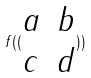Convert formula to latex. <formula><loc_0><loc_0><loc_500><loc_500>f ( ( \begin{matrix} a & b \\ c & d \end{matrix} ) )</formula> 